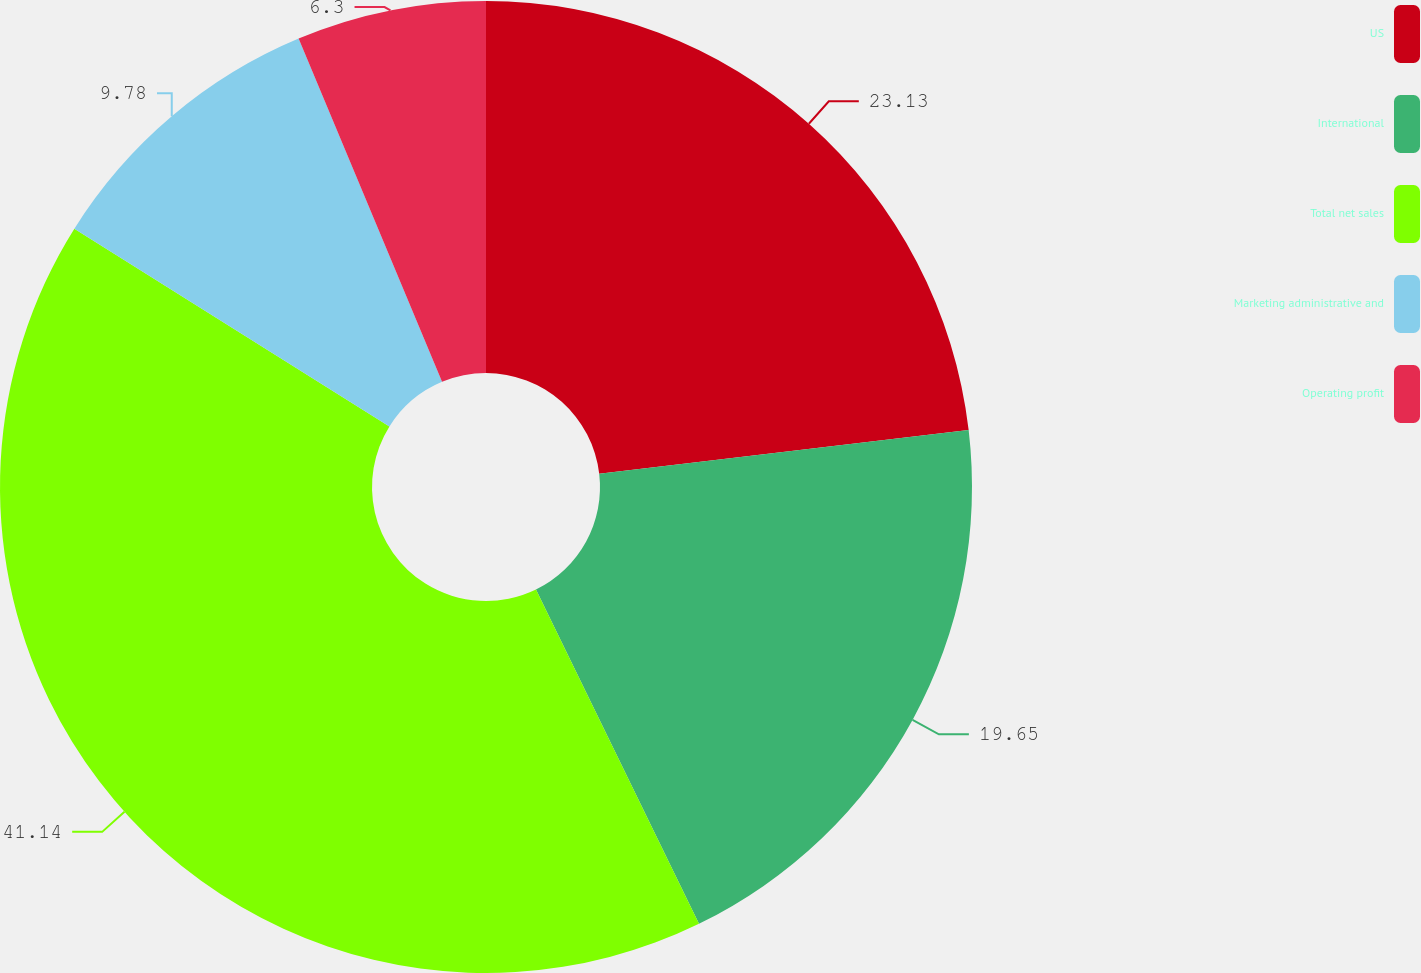Convert chart. <chart><loc_0><loc_0><loc_500><loc_500><pie_chart><fcel>US<fcel>International<fcel>Total net sales<fcel>Marketing administrative and<fcel>Operating profit<nl><fcel>23.13%<fcel>19.65%<fcel>41.14%<fcel>9.78%<fcel>6.3%<nl></chart> 